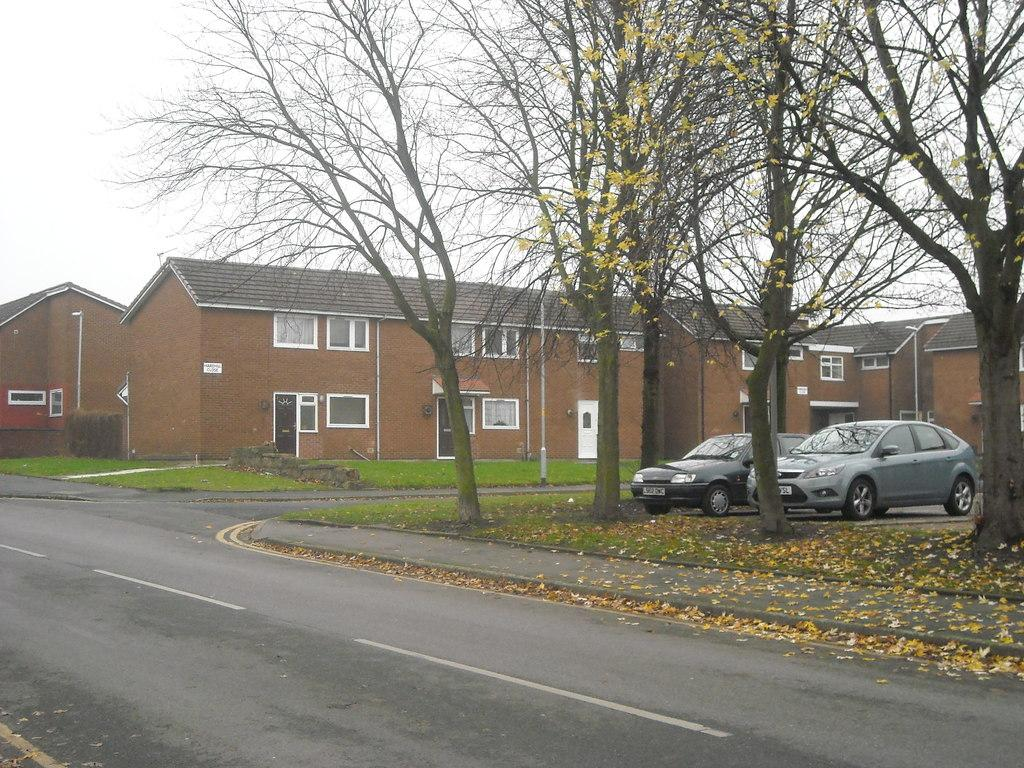What type of surface can be seen in the image? There is a road and ground with grass visible in the image. What additional elements can be found on the ground? Dry leaves are present in the image. What types of man-made structures are visible in the image? There are buildings and poles visible in the image. What is the primary mode of transportation depicted in the image? There are vehicles in the image. What natural element is visible in the image? The sky is visible in the image. Reasoning: Let'g: Let's think step by step in order to produce the conversation. We start by identifying the main surface in the image, which is the road and ground with grass. Then, we expand the conversation to include other elements found on the ground, such as dry leaves. Next, we focus on the man-made structures visible in the image, which are buildings and poles. We then mention the primary mode of transportation depicted, which are vehicles. Finally, we acknowledge the presence of the sky as a natural element in the image. Absurd Question/Answer: Can you see any fairies flying around the vehicles in the image? No, there are no fairies present in the image. What type of apple is being used as a prop in the image? There is no apple present in the image. 